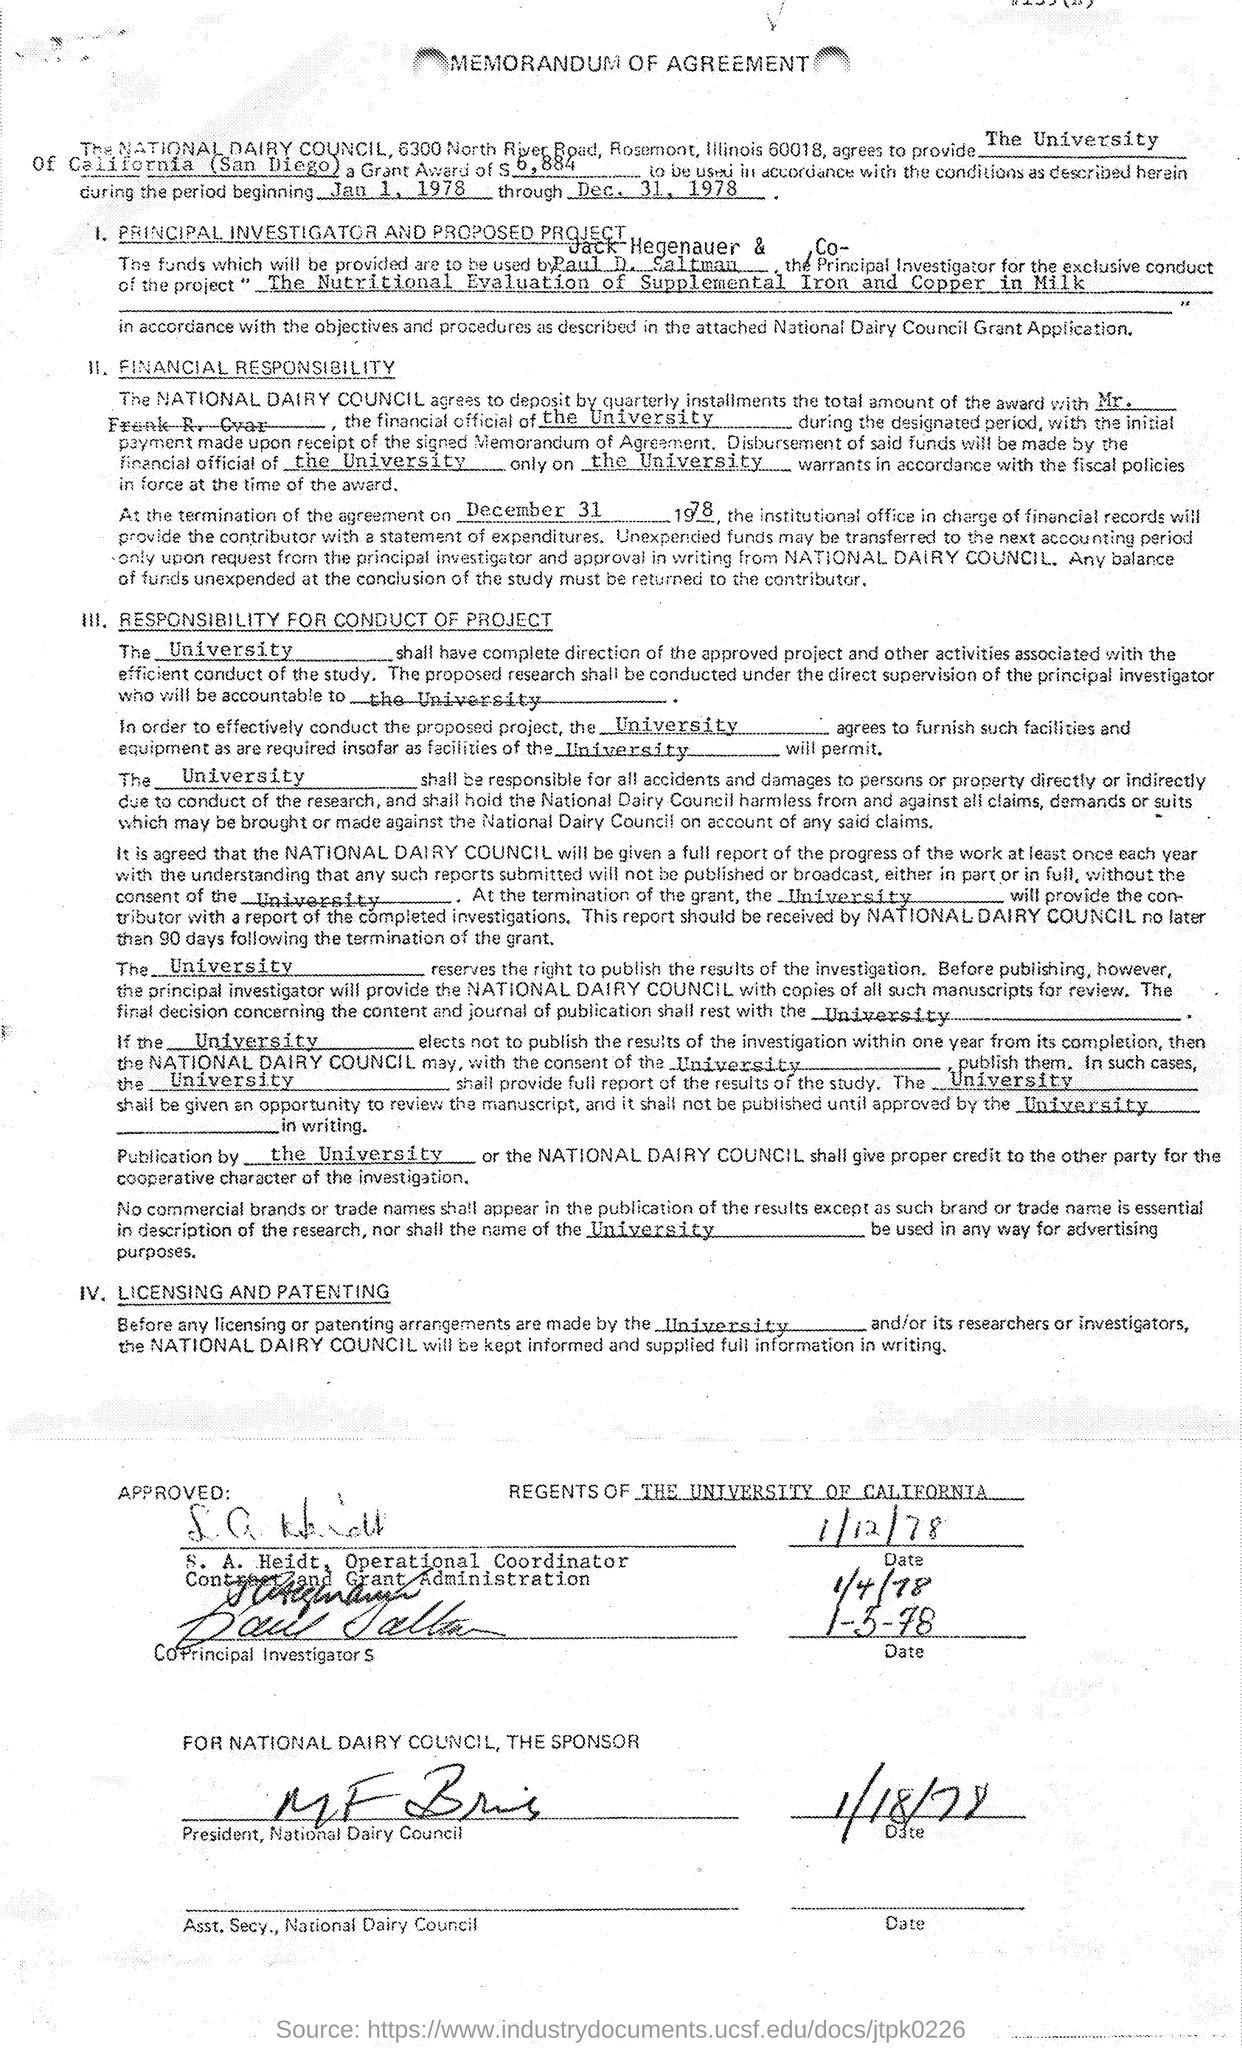Draw attention to some important aspects in this diagram. The date of termination of the agreement, as mentioned in the agreement, is December 31, 1978. The memorandum of agreement mentions the University of California, San Diego. The amount of the grant award mentioned in the given agreement is $6,884. The project mentioned in the given agreement is the nutritional evaluation of supplemental iron and copper in milk. 